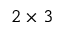<formula> <loc_0><loc_0><loc_500><loc_500>2 \times 3</formula> 